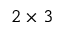<formula> <loc_0><loc_0><loc_500><loc_500>2 \times 3</formula> 